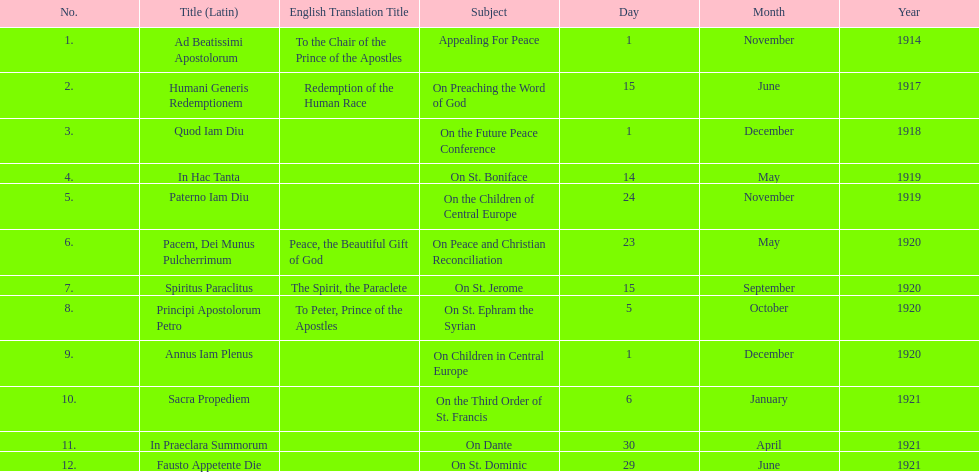What was the number of encyclopedias that had subjects relating specifically to children? 2. 